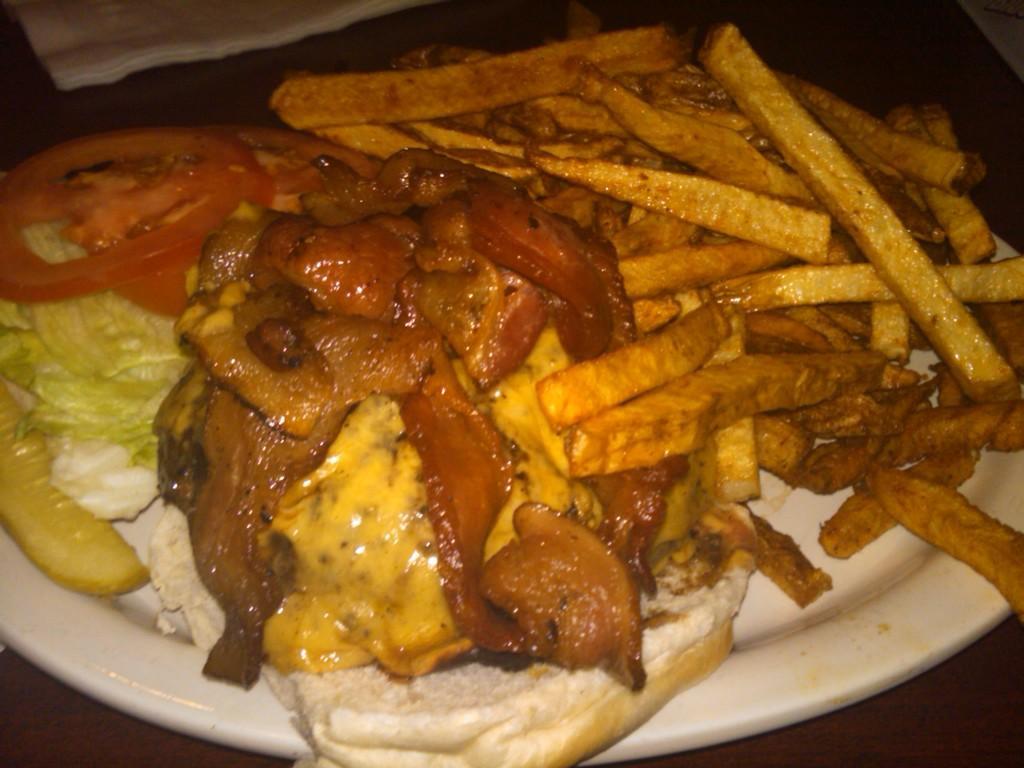In one or two sentences, can you explain what this image depicts? In this image, we can see a plate contains some food. 